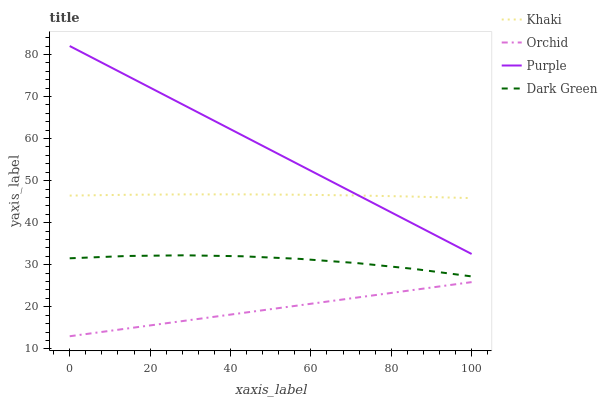Does Orchid have the minimum area under the curve?
Answer yes or no. Yes. Does Purple have the maximum area under the curve?
Answer yes or no. Yes. Does Khaki have the minimum area under the curve?
Answer yes or no. No. Does Khaki have the maximum area under the curve?
Answer yes or no. No. Is Orchid the smoothest?
Answer yes or no. Yes. Is Dark Green the roughest?
Answer yes or no. Yes. Is Khaki the smoothest?
Answer yes or no. No. Is Khaki the roughest?
Answer yes or no. No. Does Orchid have the lowest value?
Answer yes or no. Yes. Does Dark Green have the lowest value?
Answer yes or no. No. Does Purple have the highest value?
Answer yes or no. Yes. Does Khaki have the highest value?
Answer yes or no. No. Is Dark Green less than Khaki?
Answer yes or no. Yes. Is Purple greater than Orchid?
Answer yes or no. Yes. Does Khaki intersect Purple?
Answer yes or no. Yes. Is Khaki less than Purple?
Answer yes or no. No. Is Khaki greater than Purple?
Answer yes or no. No. Does Dark Green intersect Khaki?
Answer yes or no. No. 